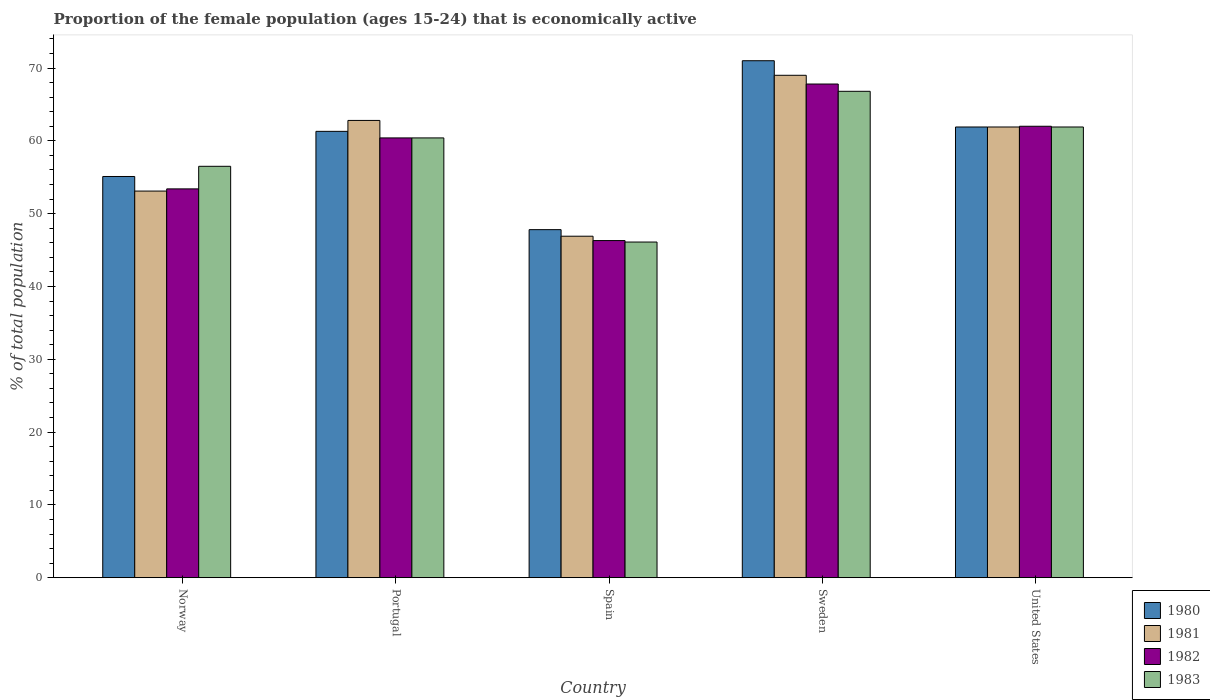How many different coloured bars are there?
Provide a short and direct response. 4. How many bars are there on the 3rd tick from the left?
Offer a terse response. 4. How many bars are there on the 3rd tick from the right?
Give a very brief answer. 4. What is the label of the 5th group of bars from the left?
Provide a succinct answer. United States. What is the proportion of the female population that is economically active in 1982 in Spain?
Keep it short and to the point. 46.3. Across all countries, what is the maximum proportion of the female population that is economically active in 1982?
Keep it short and to the point. 67.8. Across all countries, what is the minimum proportion of the female population that is economically active in 1981?
Give a very brief answer. 46.9. What is the total proportion of the female population that is economically active in 1983 in the graph?
Give a very brief answer. 291.7. What is the difference between the proportion of the female population that is economically active in 1980 in Spain and that in Sweden?
Your response must be concise. -23.2. What is the difference between the proportion of the female population that is economically active in 1981 in Norway and the proportion of the female population that is economically active in 1980 in Sweden?
Keep it short and to the point. -17.9. What is the average proportion of the female population that is economically active in 1983 per country?
Ensure brevity in your answer.  58.34. What is the difference between the proportion of the female population that is economically active of/in 1982 and proportion of the female population that is economically active of/in 1981 in Portugal?
Your response must be concise. -2.4. In how many countries, is the proportion of the female population that is economically active in 1983 greater than 18 %?
Your response must be concise. 5. What is the ratio of the proportion of the female population that is economically active in 1982 in Spain to that in United States?
Provide a short and direct response. 0.75. Is the proportion of the female population that is economically active in 1980 in Norway less than that in United States?
Your response must be concise. Yes. What is the difference between the highest and the second highest proportion of the female population that is economically active in 1981?
Offer a terse response. -7.1. What is the difference between the highest and the lowest proportion of the female population that is economically active in 1982?
Ensure brevity in your answer.  21.5. Is the sum of the proportion of the female population that is economically active in 1982 in Spain and Sweden greater than the maximum proportion of the female population that is economically active in 1983 across all countries?
Your response must be concise. Yes. Is it the case that in every country, the sum of the proportion of the female population that is economically active in 1983 and proportion of the female population that is economically active in 1981 is greater than the sum of proportion of the female population that is economically active in 1980 and proportion of the female population that is economically active in 1982?
Offer a very short reply. No. What does the 4th bar from the right in Norway represents?
Your answer should be very brief. 1980. How many bars are there?
Offer a terse response. 20. How many countries are there in the graph?
Provide a short and direct response. 5. Are the values on the major ticks of Y-axis written in scientific E-notation?
Make the answer very short. No. What is the title of the graph?
Offer a terse response. Proportion of the female population (ages 15-24) that is economically active. What is the label or title of the Y-axis?
Make the answer very short. % of total population. What is the % of total population of 1980 in Norway?
Provide a succinct answer. 55.1. What is the % of total population of 1981 in Norway?
Provide a succinct answer. 53.1. What is the % of total population in 1982 in Norway?
Your response must be concise. 53.4. What is the % of total population of 1983 in Norway?
Provide a short and direct response. 56.5. What is the % of total population of 1980 in Portugal?
Your answer should be compact. 61.3. What is the % of total population of 1981 in Portugal?
Your response must be concise. 62.8. What is the % of total population of 1982 in Portugal?
Offer a very short reply. 60.4. What is the % of total population of 1983 in Portugal?
Your answer should be compact. 60.4. What is the % of total population of 1980 in Spain?
Make the answer very short. 47.8. What is the % of total population in 1981 in Spain?
Keep it short and to the point. 46.9. What is the % of total population in 1982 in Spain?
Provide a succinct answer. 46.3. What is the % of total population in 1983 in Spain?
Ensure brevity in your answer.  46.1. What is the % of total population in 1980 in Sweden?
Your response must be concise. 71. What is the % of total population of 1981 in Sweden?
Offer a terse response. 69. What is the % of total population in 1982 in Sweden?
Your response must be concise. 67.8. What is the % of total population in 1983 in Sweden?
Your answer should be compact. 66.8. What is the % of total population in 1980 in United States?
Your response must be concise. 61.9. What is the % of total population in 1981 in United States?
Your answer should be very brief. 61.9. What is the % of total population of 1983 in United States?
Offer a terse response. 61.9. Across all countries, what is the maximum % of total population in 1982?
Provide a succinct answer. 67.8. Across all countries, what is the maximum % of total population of 1983?
Offer a terse response. 66.8. Across all countries, what is the minimum % of total population in 1980?
Give a very brief answer. 47.8. Across all countries, what is the minimum % of total population of 1981?
Your response must be concise. 46.9. Across all countries, what is the minimum % of total population in 1982?
Offer a terse response. 46.3. Across all countries, what is the minimum % of total population of 1983?
Make the answer very short. 46.1. What is the total % of total population in 1980 in the graph?
Your answer should be very brief. 297.1. What is the total % of total population in 1981 in the graph?
Your answer should be compact. 293.7. What is the total % of total population in 1982 in the graph?
Keep it short and to the point. 289.9. What is the total % of total population of 1983 in the graph?
Keep it short and to the point. 291.7. What is the difference between the % of total population in 1980 in Norway and that in Portugal?
Make the answer very short. -6.2. What is the difference between the % of total population of 1983 in Norway and that in Portugal?
Ensure brevity in your answer.  -3.9. What is the difference between the % of total population in 1980 in Norway and that in Spain?
Make the answer very short. 7.3. What is the difference between the % of total population in 1981 in Norway and that in Spain?
Provide a short and direct response. 6.2. What is the difference between the % of total population in 1982 in Norway and that in Spain?
Provide a succinct answer. 7.1. What is the difference between the % of total population of 1980 in Norway and that in Sweden?
Your answer should be very brief. -15.9. What is the difference between the % of total population in 1981 in Norway and that in Sweden?
Your answer should be compact. -15.9. What is the difference between the % of total population of 1982 in Norway and that in Sweden?
Give a very brief answer. -14.4. What is the difference between the % of total population of 1983 in Norway and that in Sweden?
Ensure brevity in your answer.  -10.3. What is the difference between the % of total population of 1980 in Norway and that in United States?
Your response must be concise. -6.8. What is the difference between the % of total population of 1981 in Norway and that in United States?
Offer a terse response. -8.8. What is the difference between the % of total population of 1983 in Norway and that in United States?
Your answer should be very brief. -5.4. What is the difference between the % of total population in 1980 in Portugal and that in Spain?
Offer a very short reply. 13.5. What is the difference between the % of total population of 1981 in Portugal and that in Spain?
Offer a terse response. 15.9. What is the difference between the % of total population of 1982 in Portugal and that in Spain?
Make the answer very short. 14.1. What is the difference between the % of total population of 1983 in Portugal and that in Spain?
Provide a succinct answer. 14.3. What is the difference between the % of total population in 1980 in Portugal and that in Sweden?
Make the answer very short. -9.7. What is the difference between the % of total population of 1980 in Portugal and that in United States?
Provide a succinct answer. -0.6. What is the difference between the % of total population of 1982 in Portugal and that in United States?
Keep it short and to the point. -1.6. What is the difference between the % of total population of 1980 in Spain and that in Sweden?
Your answer should be very brief. -23.2. What is the difference between the % of total population of 1981 in Spain and that in Sweden?
Provide a succinct answer. -22.1. What is the difference between the % of total population in 1982 in Spain and that in Sweden?
Provide a succinct answer. -21.5. What is the difference between the % of total population in 1983 in Spain and that in Sweden?
Your answer should be compact. -20.7. What is the difference between the % of total population in 1980 in Spain and that in United States?
Provide a succinct answer. -14.1. What is the difference between the % of total population of 1981 in Spain and that in United States?
Provide a succinct answer. -15. What is the difference between the % of total population in 1982 in Spain and that in United States?
Ensure brevity in your answer.  -15.7. What is the difference between the % of total population in 1983 in Spain and that in United States?
Provide a short and direct response. -15.8. What is the difference between the % of total population in 1981 in Sweden and that in United States?
Keep it short and to the point. 7.1. What is the difference between the % of total population of 1980 in Norway and the % of total population of 1981 in Portugal?
Offer a terse response. -7.7. What is the difference between the % of total population in 1980 in Norway and the % of total population in 1982 in Portugal?
Keep it short and to the point. -5.3. What is the difference between the % of total population in 1980 in Norway and the % of total population in 1983 in Portugal?
Offer a very short reply. -5.3. What is the difference between the % of total population of 1981 in Norway and the % of total population of 1982 in Portugal?
Keep it short and to the point. -7.3. What is the difference between the % of total population in 1981 in Norway and the % of total population in 1983 in Portugal?
Provide a succinct answer. -7.3. What is the difference between the % of total population of 1980 in Norway and the % of total population of 1981 in Spain?
Offer a very short reply. 8.2. What is the difference between the % of total population in 1980 in Norway and the % of total population in 1982 in Spain?
Provide a short and direct response. 8.8. What is the difference between the % of total population of 1980 in Norway and the % of total population of 1983 in Spain?
Offer a very short reply. 9. What is the difference between the % of total population in 1981 in Norway and the % of total population in 1982 in Spain?
Give a very brief answer. 6.8. What is the difference between the % of total population in 1981 in Norway and the % of total population in 1983 in Spain?
Offer a terse response. 7. What is the difference between the % of total population of 1982 in Norway and the % of total population of 1983 in Spain?
Provide a short and direct response. 7.3. What is the difference between the % of total population in 1980 in Norway and the % of total population in 1983 in Sweden?
Offer a terse response. -11.7. What is the difference between the % of total population in 1981 in Norway and the % of total population in 1982 in Sweden?
Your response must be concise. -14.7. What is the difference between the % of total population of 1981 in Norway and the % of total population of 1983 in Sweden?
Provide a succinct answer. -13.7. What is the difference between the % of total population of 1982 in Norway and the % of total population of 1983 in Sweden?
Your response must be concise. -13.4. What is the difference between the % of total population in 1980 in Norway and the % of total population in 1982 in United States?
Provide a short and direct response. -6.9. What is the difference between the % of total population of 1980 in Norway and the % of total population of 1983 in United States?
Provide a succinct answer. -6.8. What is the difference between the % of total population in 1981 in Norway and the % of total population in 1982 in United States?
Keep it short and to the point. -8.9. What is the difference between the % of total population of 1980 in Portugal and the % of total population of 1981 in Spain?
Ensure brevity in your answer.  14.4. What is the difference between the % of total population in 1981 in Portugal and the % of total population in 1983 in Spain?
Offer a terse response. 16.7. What is the difference between the % of total population in 1982 in Portugal and the % of total population in 1983 in Spain?
Offer a terse response. 14.3. What is the difference between the % of total population in 1980 in Portugal and the % of total population in 1981 in Sweden?
Provide a succinct answer. -7.7. What is the difference between the % of total population of 1982 in Portugal and the % of total population of 1983 in Sweden?
Your answer should be very brief. -6.4. What is the difference between the % of total population in 1980 in Portugal and the % of total population in 1982 in United States?
Provide a succinct answer. -0.7. What is the difference between the % of total population in 1980 in Portugal and the % of total population in 1983 in United States?
Offer a terse response. -0.6. What is the difference between the % of total population of 1982 in Portugal and the % of total population of 1983 in United States?
Offer a very short reply. -1.5. What is the difference between the % of total population of 1980 in Spain and the % of total population of 1981 in Sweden?
Keep it short and to the point. -21.2. What is the difference between the % of total population of 1980 in Spain and the % of total population of 1983 in Sweden?
Offer a very short reply. -19. What is the difference between the % of total population in 1981 in Spain and the % of total population in 1982 in Sweden?
Make the answer very short. -20.9. What is the difference between the % of total population of 1981 in Spain and the % of total population of 1983 in Sweden?
Give a very brief answer. -19.9. What is the difference between the % of total population in 1982 in Spain and the % of total population in 1983 in Sweden?
Ensure brevity in your answer.  -20.5. What is the difference between the % of total population in 1980 in Spain and the % of total population in 1981 in United States?
Provide a short and direct response. -14.1. What is the difference between the % of total population of 1980 in Spain and the % of total population of 1982 in United States?
Ensure brevity in your answer.  -14.2. What is the difference between the % of total population in 1980 in Spain and the % of total population in 1983 in United States?
Offer a very short reply. -14.1. What is the difference between the % of total population of 1981 in Spain and the % of total population of 1982 in United States?
Ensure brevity in your answer.  -15.1. What is the difference between the % of total population of 1981 in Spain and the % of total population of 1983 in United States?
Provide a short and direct response. -15. What is the difference between the % of total population in 1982 in Spain and the % of total population in 1983 in United States?
Give a very brief answer. -15.6. What is the difference between the % of total population of 1981 in Sweden and the % of total population of 1983 in United States?
Provide a succinct answer. 7.1. What is the difference between the % of total population of 1982 in Sweden and the % of total population of 1983 in United States?
Keep it short and to the point. 5.9. What is the average % of total population in 1980 per country?
Your answer should be very brief. 59.42. What is the average % of total population of 1981 per country?
Give a very brief answer. 58.74. What is the average % of total population in 1982 per country?
Offer a terse response. 57.98. What is the average % of total population of 1983 per country?
Offer a very short reply. 58.34. What is the difference between the % of total population of 1980 and % of total population of 1982 in Norway?
Your answer should be compact. 1.7. What is the difference between the % of total population of 1980 and % of total population of 1983 in Norway?
Your answer should be compact. -1.4. What is the difference between the % of total population in 1981 and % of total population in 1982 in Norway?
Provide a short and direct response. -0.3. What is the difference between the % of total population of 1982 and % of total population of 1983 in Norway?
Your response must be concise. -3.1. What is the difference between the % of total population of 1980 and % of total population of 1981 in Portugal?
Provide a short and direct response. -1.5. What is the difference between the % of total population in 1981 and % of total population in 1982 in Portugal?
Make the answer very short. 2.4. What is the difference between the % of total population in 1981 and % of total population in 1983 in Portugal?
Make the answer very short. 2.4. What is the difference between the % of total population in 1980 and % of total population in 1981 in Spain?
Your answer should be very brief. 0.9. What is the difference between the % of total population of 1980 and % of total population of 1982 in Spain?
Offer a very short reply. 1.5. What is the difference between the % of total population in 1980 and % of total population in 1983 in Spain?
Your answer should be very brief. 1.7. What is the difference between the % of total population in 1981 and % of total population in 1983 in Spain?
Provide a short and direct response. 0.8. What is the difference between the % of total population of 1982 and % of total population of 1983 in Spain?
Provide a succinct answer. 0.2. What is the difference between the % of total population of 1980 and % of total population of 1981 in Sweden?
Your answer should be compact. 2. What is the difference between the % of total population in 1980 and % of total population in 1982 in Sweden?
Your answer should be very brief. 3.2. What is the difference between the % of total population of 1980 and % of total population of 1983 in Sweden?
Provide a short and direct response. 4.2. What is the difference between the % of total population in 1981 and % of total population in 1983 in Sweden?
Give a very brief answer. 2.2. What is the difference between the % of total population in 1982 and % of total population in 1983 in Sweden?
Make the answer very short. 1. What is the ratio of the % of total population of 1980 in Norway to that in Portugal?
Give a very brief answer. 0.9. What is the ratio of the % of total population in 1981 in Norway to that in Portugal?
Ensure brevity in your answer.  0.85. What is the ratio of the % of total population of 1982 in Norway to that in Portugal?
Provide a succinct answer. 0.88. What is the ratio of the % of total population in 1983 in Norway to that in Portugal?
Your answer should be compact. 0.94. What is the ratio of the % of total population of 1980 in Norway to that in Spain?
Your response must be concise. 1.15. What is the ratio of the % of total population of 1981 in Norway to that in Spain?
Your answer should be very brief. 1.13. What is the ratio of the % of total population of 1982 in Norway to that in Spain?
Your response must be concise. 1.15. What is the ratio of the % of total population of 1983 in Norway to that in Spain?
Make the answer very short. 1.23. What is the ratio of the % of total population in 1980 in Norway to that in Sweden?
Your answer should be very brief. 0.78. What is the ratio of the % of total population in 1981 in Norway to that in Sweden?
Offer a terse response. 0.77. What is the ratio of the % of total population of 1982 in Norway to that in Sweden?
Give a very brief answer. 0.79. What is the ratio of the % of total population of 1983 in Norway to that in Sweden?
Your answer should be compact. 0.85. What is the ratio of the % of total population of 1980 in Norway to that in United States?
Ensure brevity in your answer.  0.89. What is the ratio of the % of total population in 1981 in Norway to that in United States?
Ensure brevity in your answer.  0.86. What is the ratio of the % of total population in 1982 in Norway to that in United States?
Your response must be concise. 0.86. What is the ratio of the % of total population of 1983 in Norway to that in United States?
Offer a very short reply. 0.91. What is the ratio of the % of total population of 1980 in Portugal to that in Spain?
Your answer should be compact. 1.28. What is the ratio of the % of total population in 1981 in Portugal to that in Spain?
Give a very brief answer. 1.34. What is the ratio of the % of total population in 1982 in Portugal to that in Spain?
Give a very brief answer. 1.3. What is the ratio of the % of total population in 1983 in Portugal to that in Spain?
Your response must be concise. 1.31. What is the ratio of the % of total population of 1980 in Portugal to that in Sweden?
Your response must be concise. 0.86. What is the ratio of the % of total population in 1981 in Portugal to that in Sweden?
Your answer should be compact. 0.91. What is the ratio of the % of total population of 1982 in Portugal to that in Sweden?
Give a very brief answer. 0.89. What is the ratio of the % of total population in 1983 in Portugal to that in Sweden?
Ensure brevity in your answer.  0.9. What is the ratio of the % of total population in 1980 in Portugal to that in United States?
Provide a short and direct response. 0.99. What is the ratio of the % of total population of 1981 in Portugal to that in United States?
Offer a terse response. 1.01. What is the ratio of the % of total population of 1982 in Portugal to that in United States?
Your answer should be very brief. 0.97. What is the ratio of the % of total population of 1983 in Portugal to that in United States?
Give a very brief answer. 0.98. What is the ratio of the % of total population of 1980 in Spain to that in Sweden?
Ensure brevity in your answer.  0.67. What is the ratio of the % of total population in 1981 in Spain to that in Sweden?
Ensure brevity in your answer.  0.68. What is the ratio of the % of total population of 1982 in Spain to that in Sweden?
Keep it short and to the point. 0.68. What is the ratio of the % of total population in 1983 in Spain to that in Sweden?
Keep it short and to the point. 0.69. What is the ratio of the % of total population in 1980 in Spain to that in United States?
Make the answer very short. 0.77. What is the ratio of the % of total population in 1981 in Spain to that in United States?
Offer a very short reply. 0.76. What is the ratio of the % of total population of 1982 in Spain to that in United States?
Your answer should be compact. 0.75. What is the ratio of the % of total population of 1983 in Spain to that in United States?
Provide a short and direct response. 0.74. What is the ratio of the % of total population in 1980 in Sweden to that in United States?
Your answer should be very brief. 1.15. What is the ratio of the % of total population of 1981 in Sweden to that in United States?
Offer a very short reply. 1.11. What is the ratio of the % of total population in 1982 in Sweden to that in United States?
Your answer should be very brief. 1.09. What is the ratio of the % of total population of 1983 in Sweden to that in United States?
Your answer should be compact. 1.08. What is the difference between the highest and the second highest % of total population in 1981?
Keep it short and to the point. 6.2. What is the difference between the highest and the lowest % of total population of 1980?
Your response must be concise. 23.2. What is the difference between the highest and the lowest % of total population in 1981?
Provide a short and direct response. 22.1. What is the difference between the highest and the lowest % of total population in 1982?
Give a very brief answer. 21.5. What is the difference between the highest and the lowest % of total population in 1983?
Offer a terse response. 20.7. 